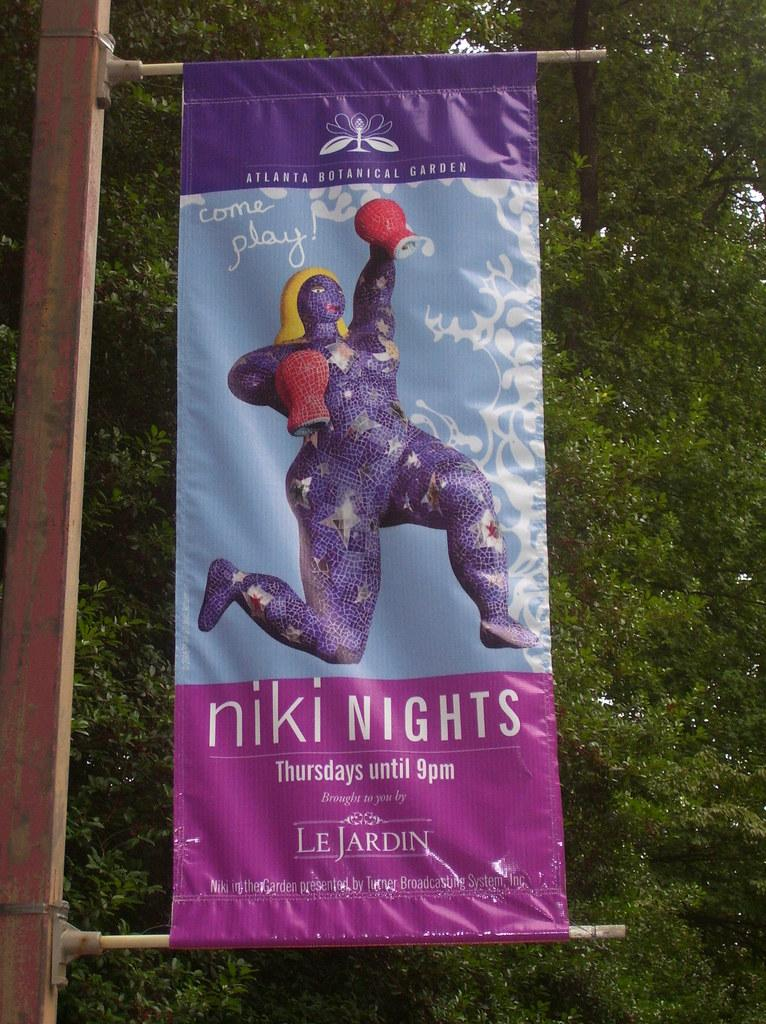<image>
Present a compact description of the photo's key features. a banner on a pole that says 'niki nights' on it 